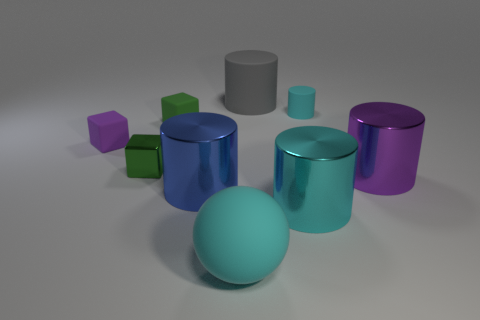What can you infer about the lighting of the scene? From the image, it seems that the lighting is coming from above, as evidenced by the shadows being cast downwards and to the sides of the objects. The light source appears to be soft and diffuse rather than a hard, point light, given that the shadows have soft edges and the highlights on the objects are not overly sharp. The overall lighting appears to be even, without harsh contrasts, which creates a calm and neutral atmosphere. 